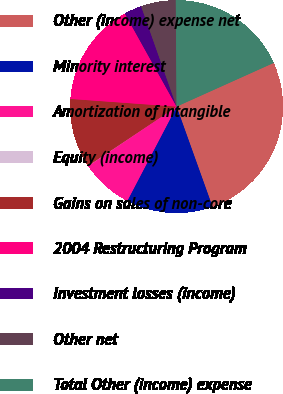<chart> <loc_0><loc_0><loc_500><loc_500><pie_chart><fcel>Other (income) expense net<fcel>Minority interest<fcel>Amortization of intangible<fcel>Equity (income)<fcel>Gains on sales of non-core<fcel>2004 Restructuring Program<fcel>Investment losses (income)<fcel>Other net<fcel>Total Other (income) expense<nl><fcel>26.25%<fcel>13.15%<fcel>7.91%<fcel>0.04%<fcel>10.53%<fcel>15.77%<fcel>2.67%<fcel>5.29%<fcel>18.39%<nl></chart> 